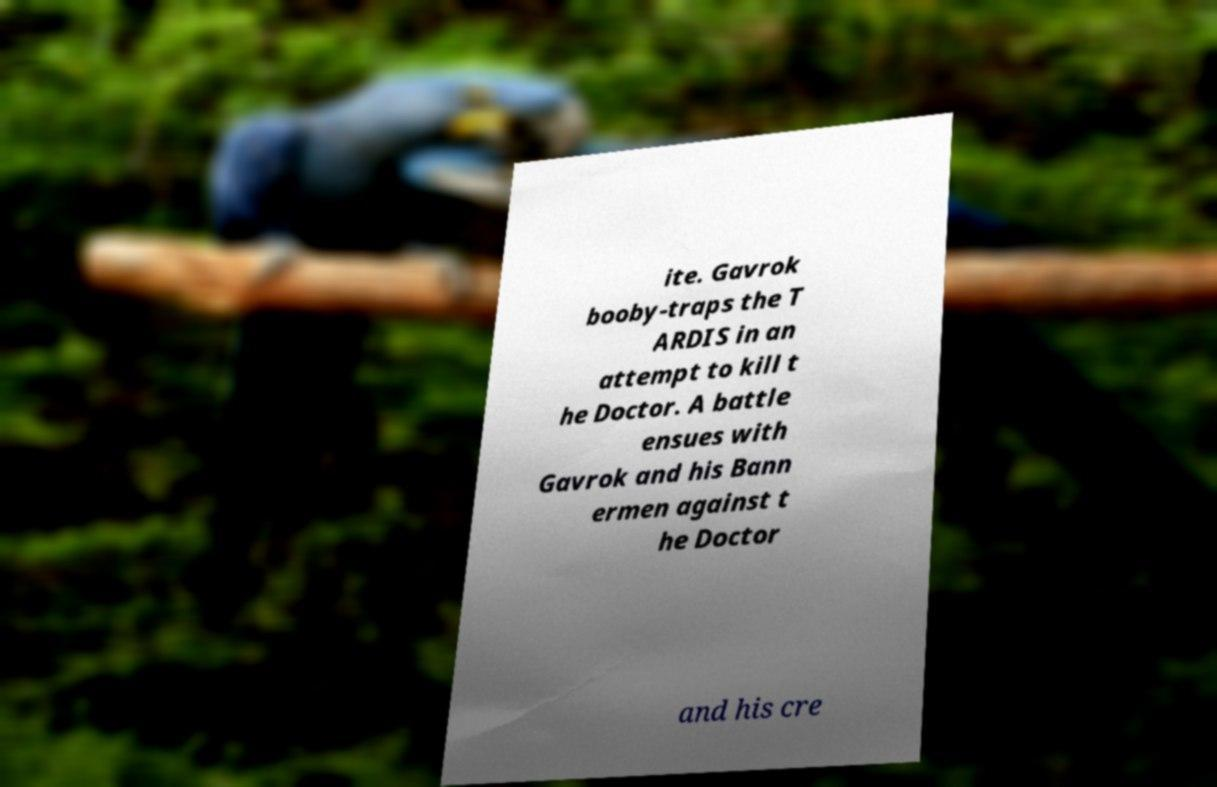Could you assist in decoding the text presented in this image and type it out clearly? ite. Gavrok booby-traps the T ARDIS in an attempt to kill t he Doctor. A battle ensues with Gavrok and his Bann ermen against t he Doctor and his cre 